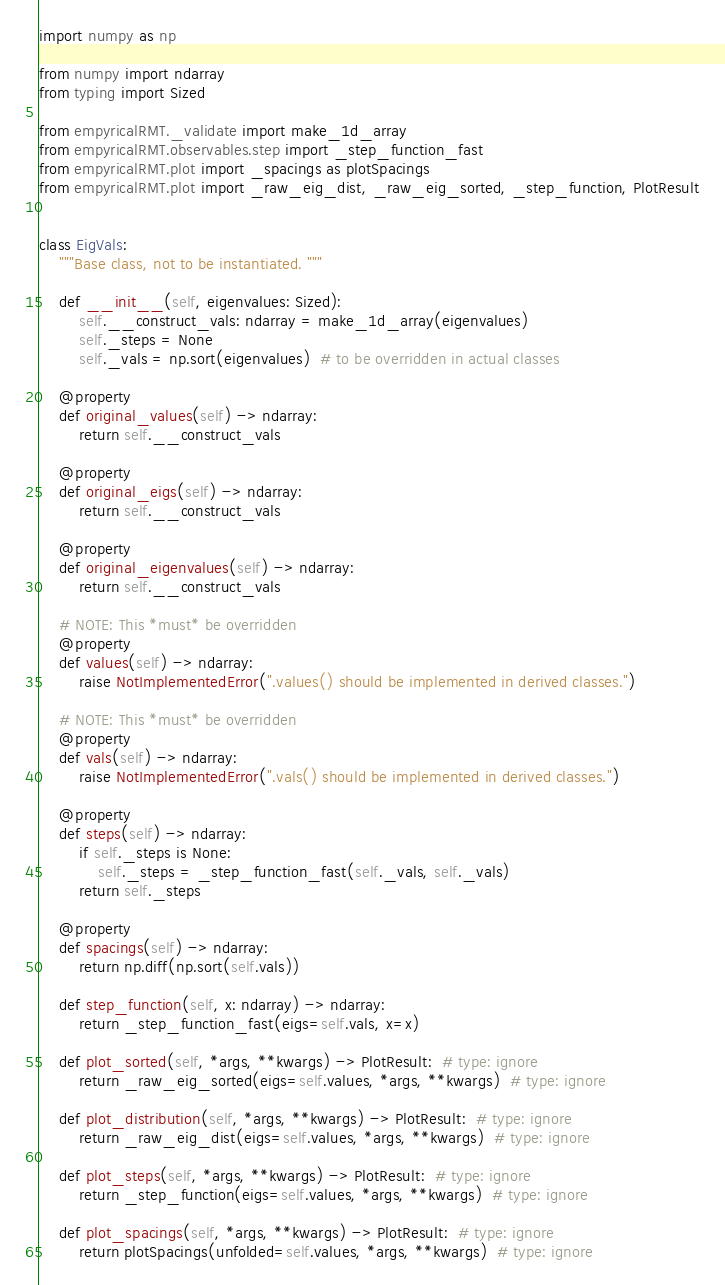<code> <loc_0><loc_0><loc_500><loc_500><_Python_>import numpy as np

from numpy import ndarray
from typing import Sized

from empyricalRMT._validate import make_1d_array
from empyricalRMT.observables.step import _step_function_fast
from empyricalRMT.plot import _spacings as plotSpacings
from empyricalRMT.plot import _raw_eig_dist, _raw_eig_sorted, _step_function, PlotResult


class EigVals:
    """Base class, not to be instantiated. """

    def __init__(self, eigenvalues: Sized):
        self.__construct_vals: ndarray = make_1d_array(eigenvalues)
        self._steps = None
        self._vals = np.sort(eigenvalues)  # to be overridden in actual classes

    @property
    def original_values(self) -> ndarray:
        return self.__construct_vals

    @property
    def original_eigs(self) -> ndarray:
        return self.__construct_vals

    @property
    def original_eigenvalues(self) -> ndarray:
        return self.__construct_vals

    # NOTE: This *must* be overridden
    @property
    def values(self) -> ndarray:
        raise NotImplementedError(".values() should be implemented in derived classes.")

    # NOTE: This *must* be overridden
    @property
    def vals(self) -> ndarray:
        raise NotImplementedError(".vals() should be implemented in derived classes.")

    @property
    def steps(self) -> ndarray:
        if self._steps is None:
            self._steps = _step_function_fast(self._vals, self._vals)
        return self._steps

    @property
    def spacings(self) -> ndarray:
        return np.diff(np.sort(self.vals))

    def step_function(self, x: ndarray) -> ndarray:
        return _step_function_fast(eigs=self.vals, x=x)

    def plot_sorted(self, *args, **kwargs) -> PlotResult:  # type: ignore
        return _raw_eig_sorted(eigs=self.values, *args, **kwargs)  # type: ignore

    def plot_distribution(self, *args, **kwargs) -> PlotResult:  # type: ignore
        return _raw_eig_dist(eigs=self.values, *args, **kwargs)  # type: ignore

    def plot_steps(self, *args, **kwargs) -> PlotResult:  # type: ignore
        return _step_function(eigs=self.values, *args, **kwargs)  # type: ignore

    def plot_spacings(self, *args, **kwargs) -> PlotResult:  # type: ignore
        return plotSpacings(unfolded=self.values, *args, **kwargs)  # type: ignore
</code> 